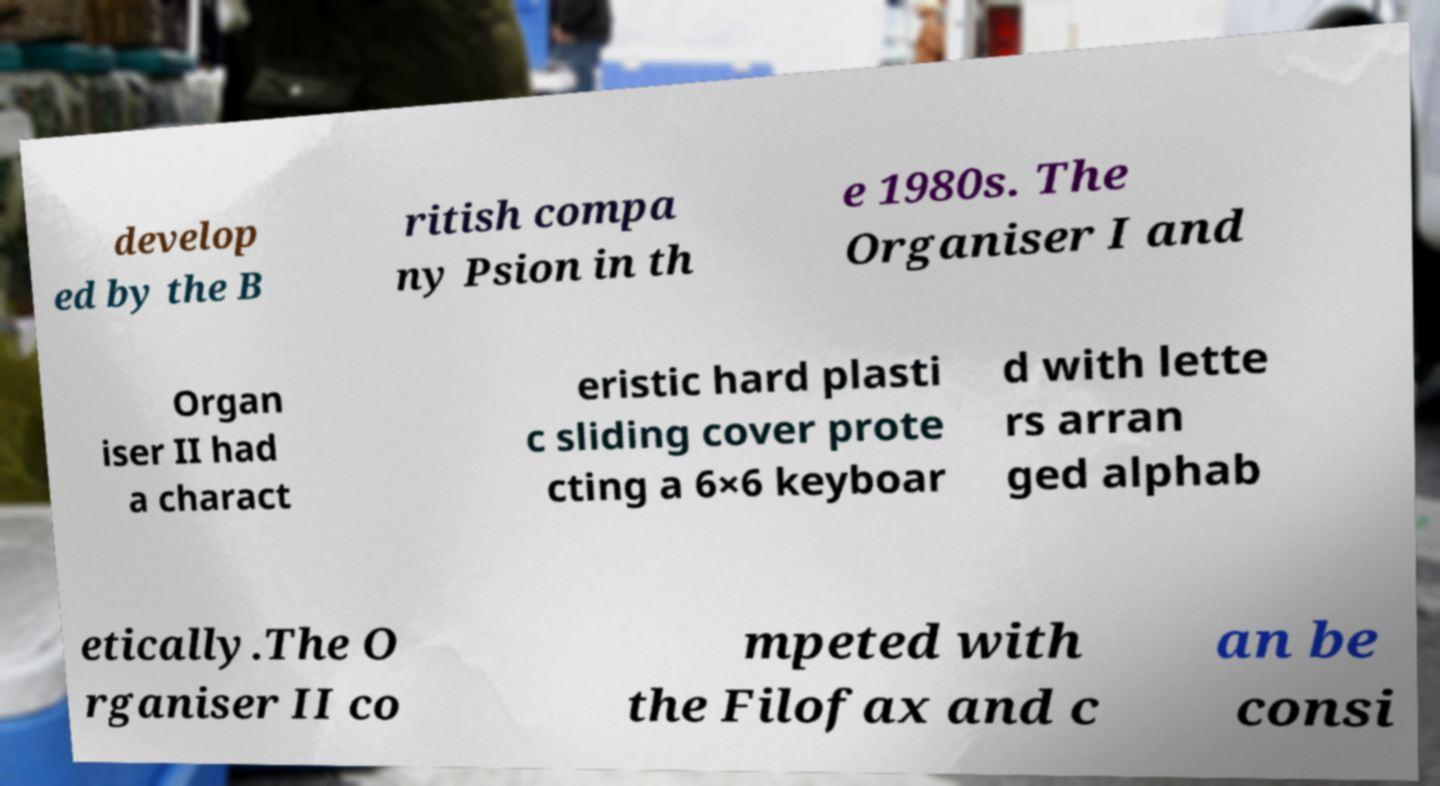Can you accurately transcribe the text from the provided image for me? develop ed by the B ritish compa ny Psion in th e 1980s. The Organiser I and Organ iser II had a charact eristic hard plasti c sliding cover prote cting a 6×6 keyboar d with lette rs arran ged alphab etically.The O rganiser II co mpeted with the Filofax and c an be consi 